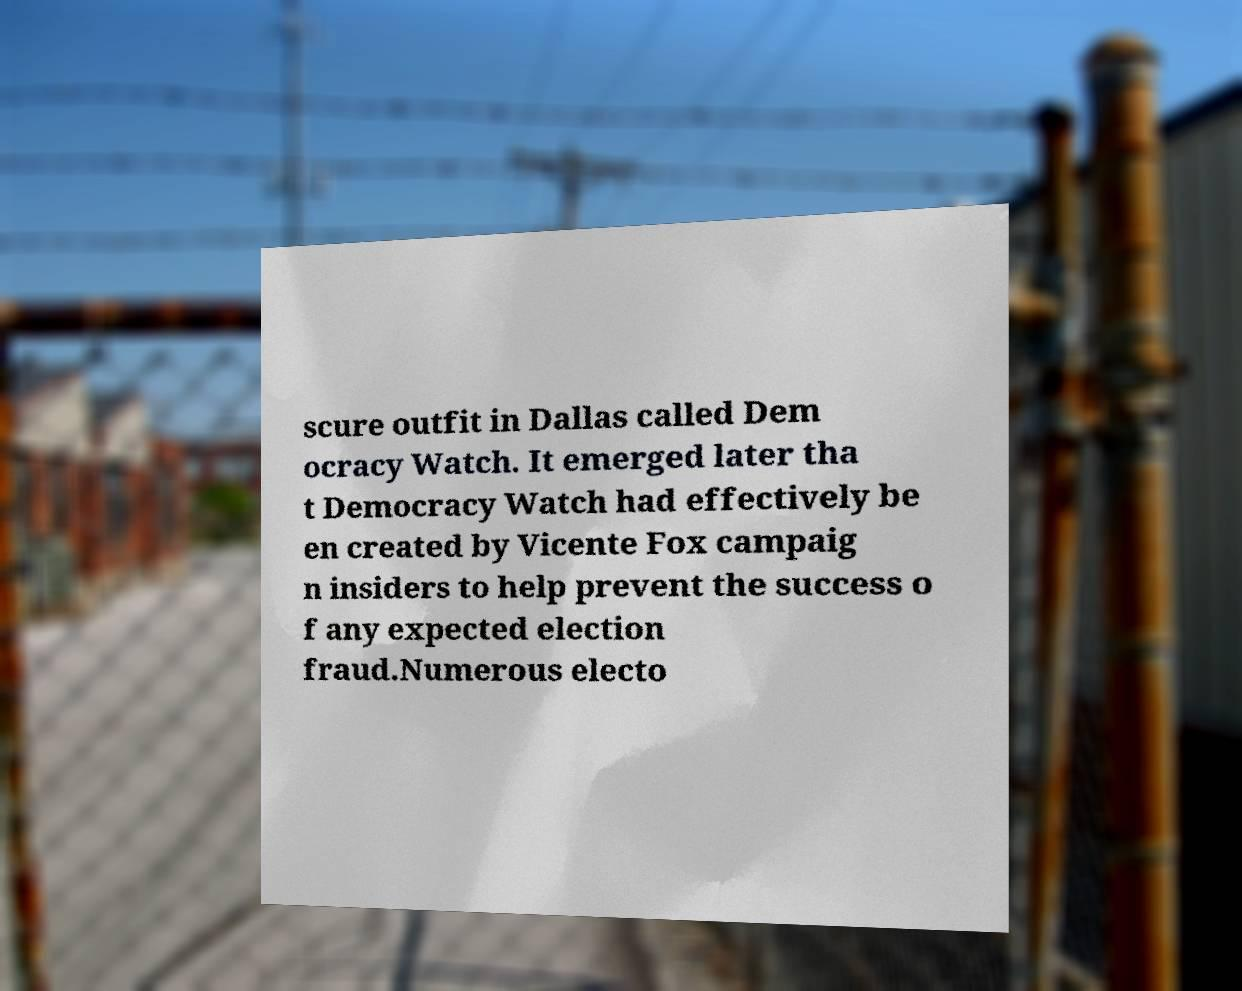Could you assist in decoding the text presented in this image and type it out clearly? scure outfit in Dallas called Dem ocracy Watch. It emerged later tha t Democracy Watch had effectively be en created by Vicente Fox campaig n insiders to help prevent the success o f any expected election fraud.Numerous electo 